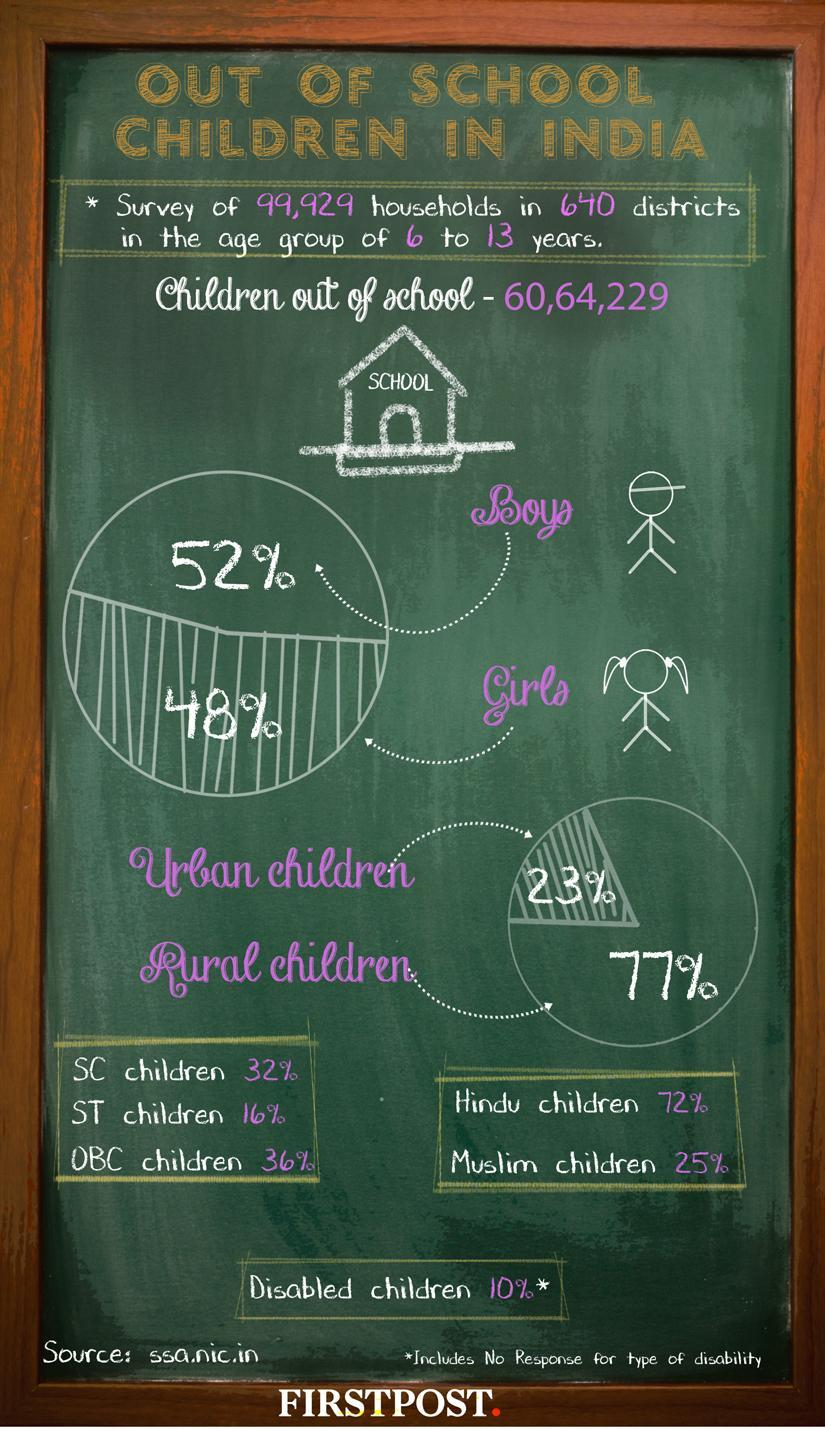How many SC/ST children are there?
Answer the question with a short phrase. 48% What percentage of children do not have any kind of disability? 90 